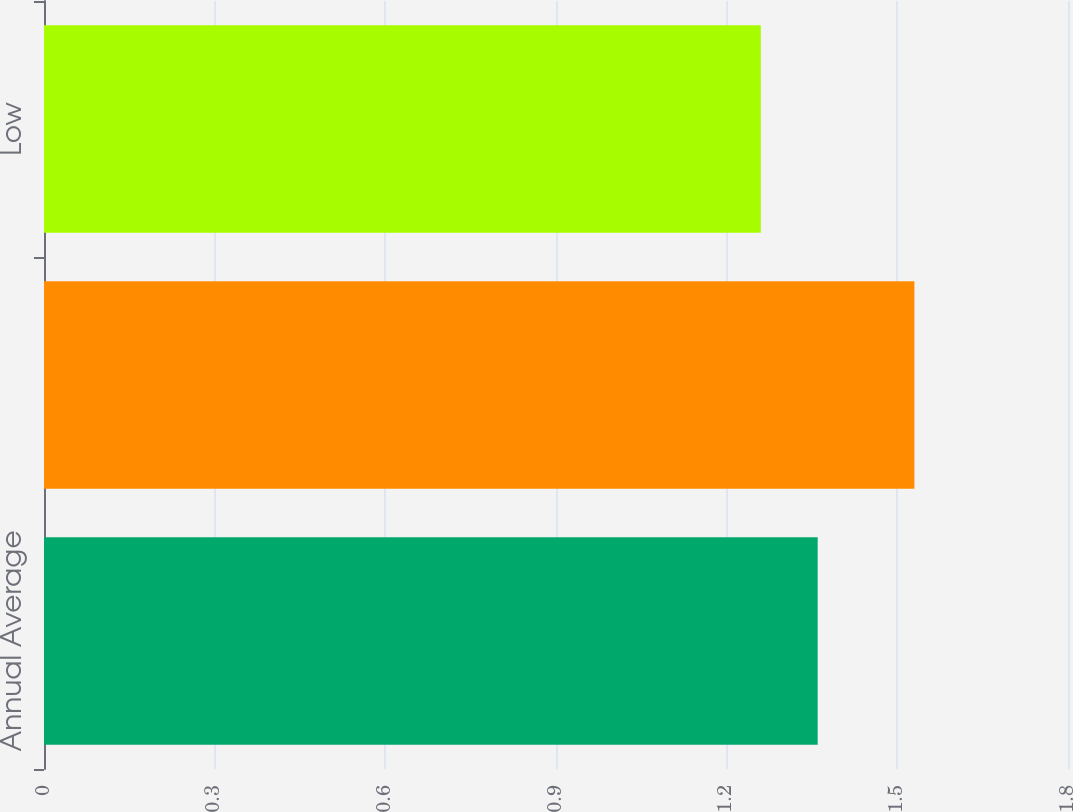Convert chart. <chart><loc_0><loc_0><loc_500><loc_500><bar_chart><fcel>Annual Average<fcel>High<fcel>Low<nl><fcel>1.36<fcel>1.53<fcel>1.26<nl></chart> 